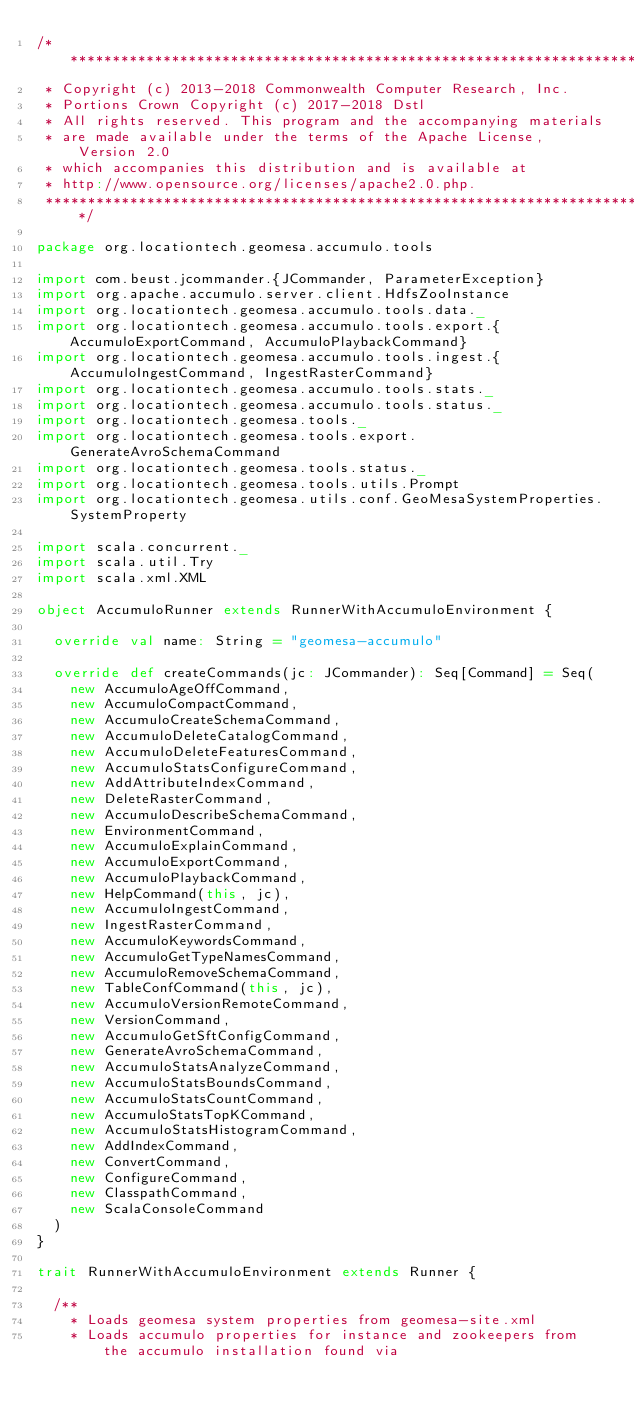Convert code to text. <code><loc_0><loc_0><loc_500><loc_500><_Scala_>/***********************************************************************
 * Copyright (c) 2013-2018 Commonwealth Computer Research, Inc.
 * Portions Crown Copyright (c) 2017-2018 Dstl
 * All rights reserved. This program and the accompanying materials
 * are made available under the terms of the Apache License, Version 2.0
 * which accompanies this distribution and is available at
 * http://www.opensource.org/licenses/apache2.0.php.
 ***********************************************************************/

package org.locationtech.geomesa.accumulo.tools

import com.beust.jcommander.{JCommander, ParameterException}
import org.apache.accumulo.server.client.HdfsZooInstance
import org.locationtech.geomesa.accumulo.tools.data._
import org.locationtech.geomesa.accumulo.tools.export.{AccumuloExportCommand, AccumuloPlaybackCommand}
import org.locationtech.geomesa.accumulo.tools.ingest.{AccumuloIngestCommand, IngestRasterCommand}
import org.locationtech.geomesa.accumulo.tools.stats._
import org.locationtech.geomesa.accumulo.tools.status._
import org.locationtech.geomesa.tools._
import org.locationtech.geomesa.tools.export.GenerateAvroSchemaCommand
import org.locationtech.geomesa.tools.status._
import org.locationtech.geomesa.tools.utils.Prompt
import org.locationtech.geomesa.utils.conf.GeoMesaSystemProperties.SystemProperty

import scala.concurrent._
import scala.util.Try
import scala.xml.XML

object AccumuloRunner extends RunnerWithAccumuloEnvironment {

  override val name: String = "geomesa-accumulo"

  override def createCommands(jc: JCommander): Seq[Command] = Seq(
    new AccumuloAgeOffCommand,
    new AccumuloCompactCommand,
    new AccumuloCreateSchemaCommand,
    new AccumuloDeleteCatalogCommand,
    new AccumuloDeleteFeaturesCommand,
    new AccumuloStatsConfigureCommand,
    new AddAttributeIndexCommand,
    new DeleteRasterCommand,
    new AccumuloDescribeSchemaCommand,
    new EnvironmentCommand,
    new AccumuloExplainCommand,
    new AccumuloExportCommand,
    new AccumuloPlaybackCommand,
    new HelpCommand(this, jc),
    new AccumuloIngestCommand,
    new IngestRasterCommand,
    new AccumuloKeywordsCommand,
    new AccumuloGetTypeNamesCommand,
    new AccumuloRemoveSchemaCommand,
    new TableConfCommand(this, jc),
    new AccumuloVersionRemoteCommand,
    new VersionCommand,
    new AccumuloGetSftConfigCommand,
    new GenerateAvroSchemaCommand,
    new AccumuloStatsAnalyzeCommand,
    new AccumuloStatsBoundsCommand,
    new AccumuloStatsCountCommand,
    new AccumuloStatsTopKCommand,
    new AccumuloStatsHistogramCommand,
    new AddIndexCommand,
    new ConvertCommand,
    new ConfigureCommand,
    new ClasspathCommand,
    new ScalaConsoleCommand
  )
}

trait RunnerWithAccumuloEnvironment extends Runner {

  /**
    * Loads geomesa system properties from geomesa-site.xml
    * Loads accumulo properties for instance and zookeepers from the accumulo installation found via</code> 